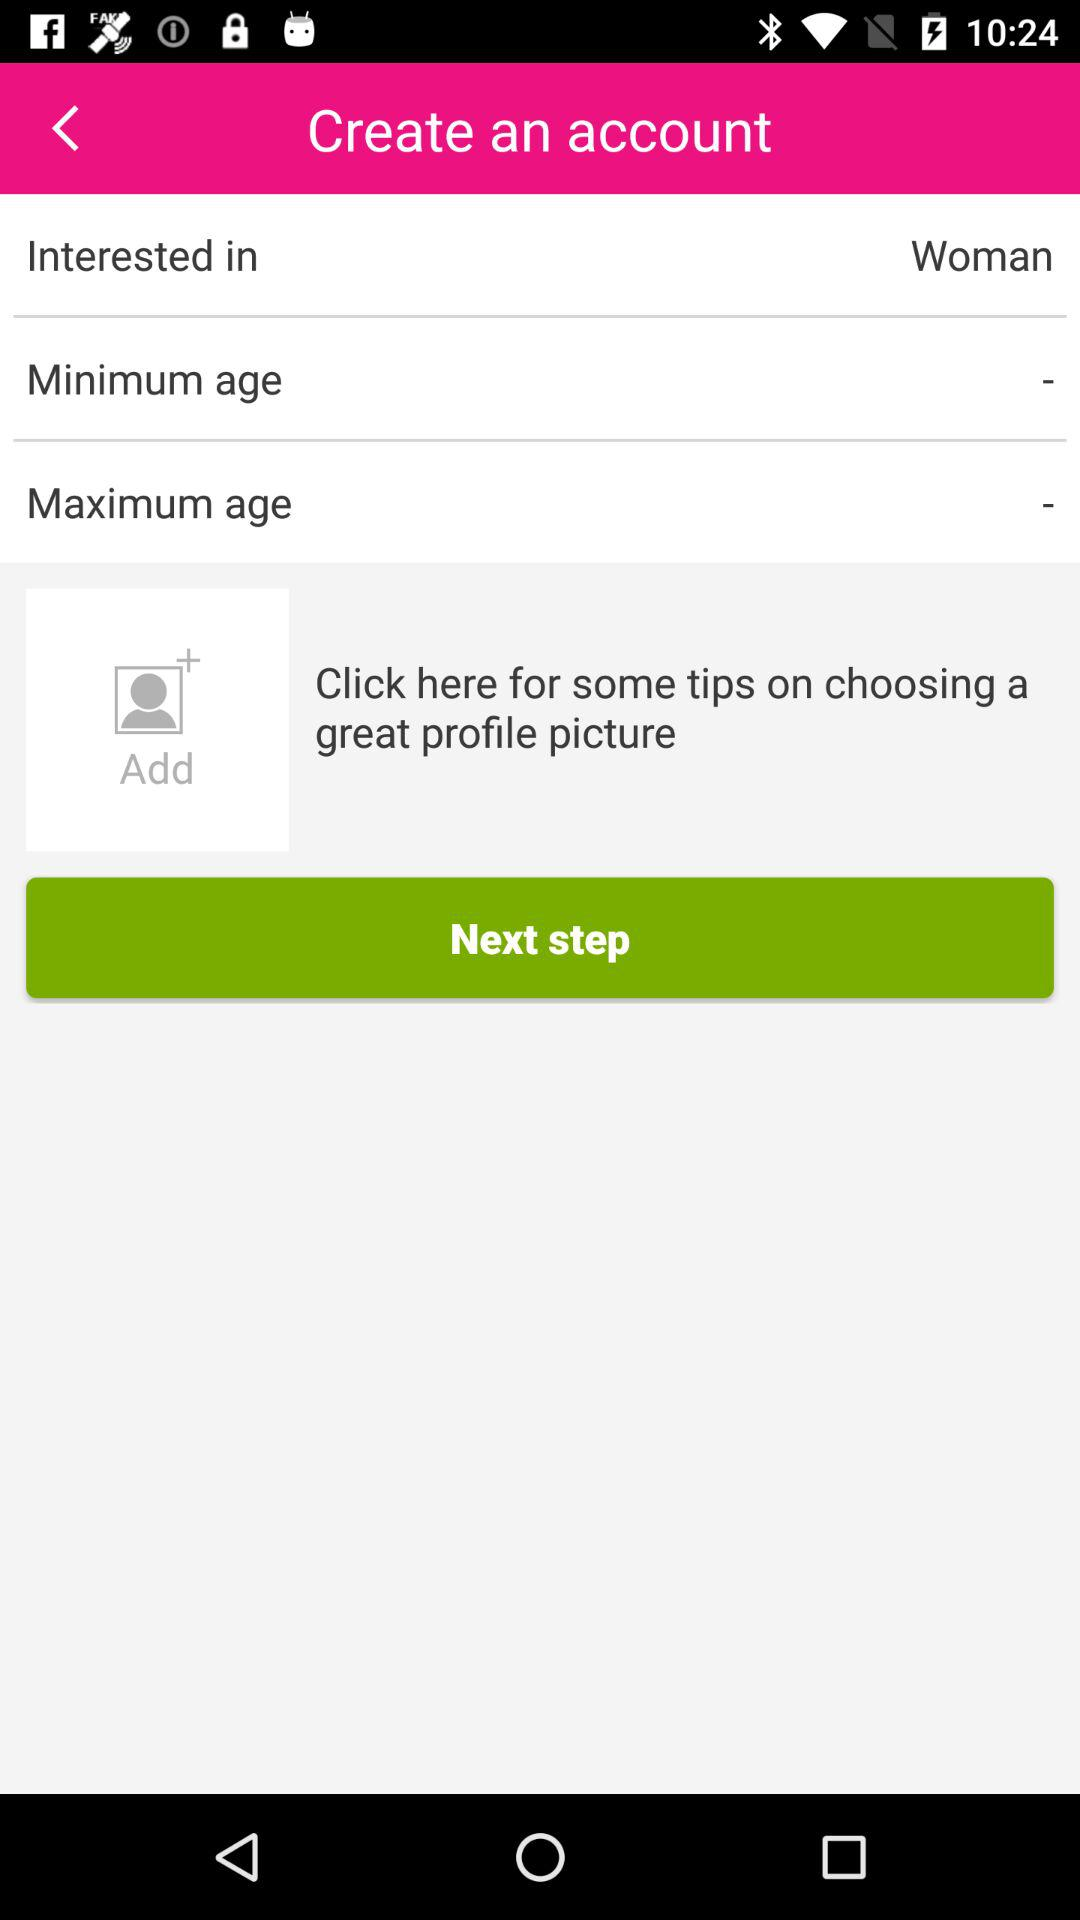In which gender is the user interested? The user is interested in "Woman". 